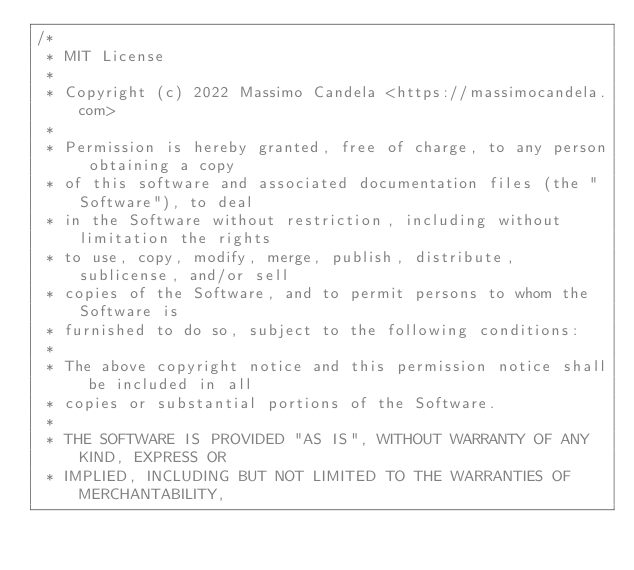Convert code to text. <code><loc_0><loc_0><loc_500><loc_500><_JavaScript_>/*
 * MIT License
 *
 * Copyright (c) 2022 Massimo Candela <https://massimocandela.com>
 *
 * Permission is hereby granted, free of charge, to any person obtaining a copy
 * of this software and associated documentation files (the "Software"), to deal
 * in the Software without restriction, including without limitation the rights
 * to use, copy, modify, merge, publish, distribute, sublicense, and/or sell
 * copies of the Software, and to permit persons to whom the Software is
 * furnished to do so, subject to the following conditions:
 *
 * The above copyright notice and this permission notice shall be included in all
 * copies or substantial portions of the Software.
 *
 * THE SOFTWARE IS PROVIDED "AS IS", WITHOUT WARRANTY OF ANY KIND, EXPRESS OR
 * IMPLIED, INCLUDING BUT NOT LIMITED TO THE WARRANTIES OF MERCHANTABILITY,</code> 